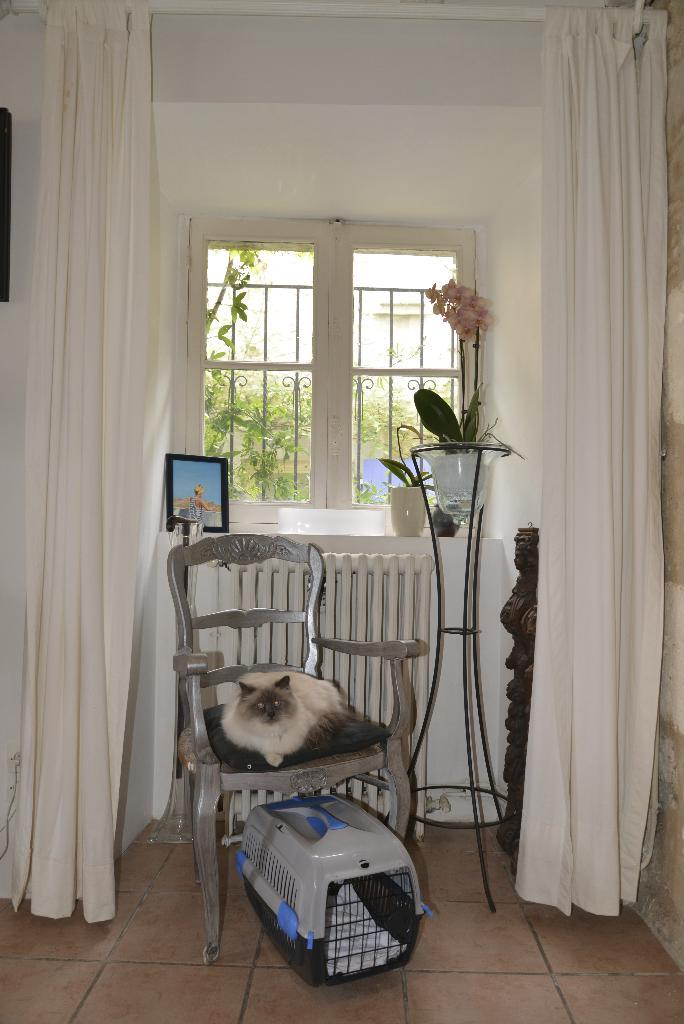What type of window treatment is visible in the image? There are curtains in the image. What is located near the curtains? There is a window in the image. What color is the wall in the image? The wall in the image is white. What type of decorative item can be seen in the image? There is a photo frame in the image. What type of furniture is present in the image? There is a chair in the image, and a cat is sitting on it. How does the cat contribute to the harmony of the historical events depicted in the photo frame? The image does not depict any historical events, and the cat's presence does not contribute to any harmony in the image. Additionally, there are no rabbits present in the image. 